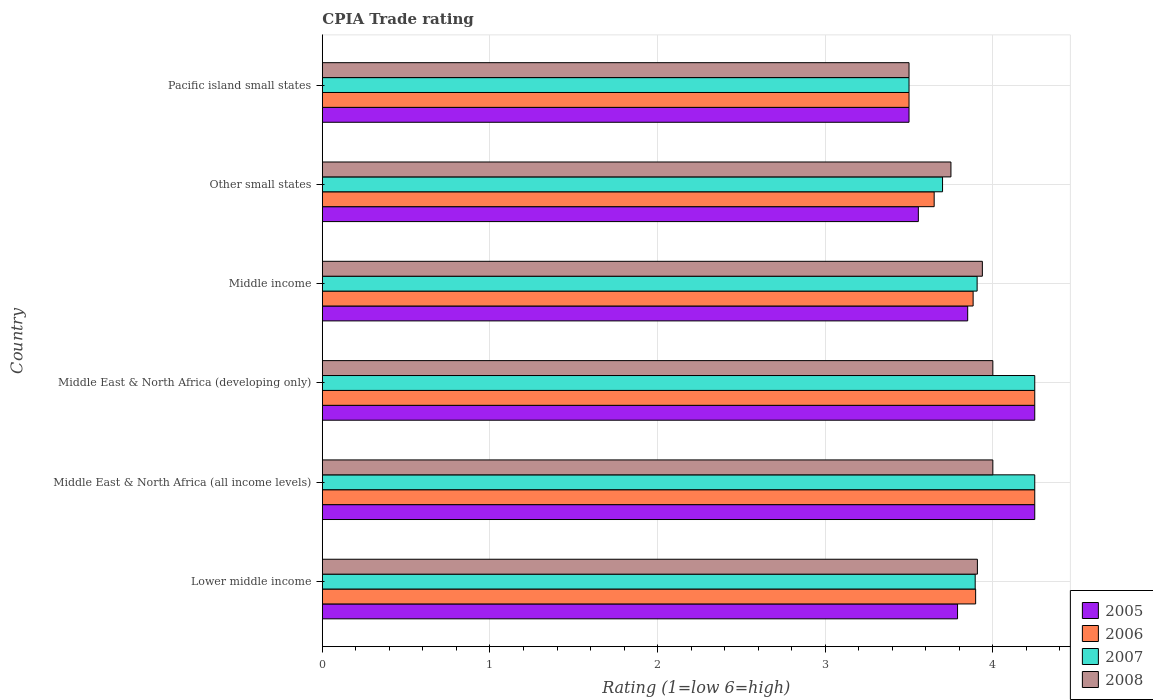Are the number of bars per tick equal to the number of legend labels?
Provide a short and direct response. Yes. How many bars are there on the 6th tick from the bottom?
Your answer should be compact. 4. What is the label of the 2nd group of bars from the top?
Offer a terse response. Other small states. In how many cases, is the number of bars for a given country not equal to the number of legend labels?
Keep it short and to the point. 0. What is the CPIA rating in 2008 in Other small states?
Provide a succinct answer. 3.75. Across all countries, what is the maximum CPIA rating in 2006?
Offer a very short reply. 4.25. Across all countries, what is the minimum CPIA rating in 2006?
Your answer should be very brief. 3.5. In which country was the CPIA rating in 2008 maximum?
Provide a short and direct response. Middle East & North Africa (all income levels). In which country was the CPIA rating in 2005 minimum?
Provide a succinct answer. Pacific island small states. What is the total CPIA rating in 2008 in the graph?
Ensure brevity in your answer.  23.1. What is the difference between the CPIA rating in 2008 in Middle East & North Africa (all income levels) and that in Middle East & North Africa (developing only)?
Your response must be concise. 0. What is the difference between the CPIA rating in 2005 in Middle East & North Africa (all income levels) and the CPIA rating in 2006 in Lower middle income?
Your response must be concise. 0.35. What is the average CPIA rating in 2007 per country?
Make the answer very short. 3.92. What is the ratio of the CPIA rating in 2006 in Middle East & North Africa (all income levels) to that in Pacific island small states?
Provide a succinct answer. 1.21. Is the difference between the CPIA rating in 2008 in Lower middle income and Pacific island small states greater than the difference between the CPIA rating in 2005 in Lower middle income and Pacific island small states?
Keep it short and to the point. Yes. What is the difference between the highest and the second highest CPIA rating in 2005?
Offer a terse response. 0. What does the 2nd bar from the bottom in Middle East & North Africa (all income levels) represents?
Give a very brief answer. 2006. Is it the case that in every country, the sum of the CPIA rating in 2007 and CPIA rating in 2005 is greater than the CPIA rating in 2006?
Ensure brevity in your answer.  Yes. How many bars are there?
Make the answer very short. 24. Are all the bars in the graph horizontal?
Your response must be concise. Yes. What is the difference between two consecutive major ticks on the X-axis?
Your answer should be compact. 1. Does the graph contain grids?
Your answer should be very brief. Yes. Where does the legend appear in the graph?
Make the answer very short. Bottom right. How are the legend labels stacked?
Ensure brevity in your answer.  Vertical. What is the title of the graph?
Your answer should be very brief. CPIA Trade rating. Does "1989" appear as one of the legend labels in the graph?
Your response must be concise. No. What is the label or title of the Y-axis?
Give a very brief answer. Country. What is the Rating (1=low 6=high) of 2005 in Lower middle income?
Provide a succinct answer. 3.79. What is the Rating (1=low 6=high) of 2006 in Lower middle income?
Keep it short and to the point. 3.9. What is the Rating (1=low 6=high) in 2007 in Lower middle income?
Provide a short and direct response. 3.89. What is the Rating (1=low 6=high) in 2008 in Lower middle income?
Your answer should be compact. 3.91. What is the Rating (1=low 6=high) in 2005 in Middle East & North Africa (all income levels)?
Keep it short and to the point. 4.25. What is the Rating (1=low 6=high) of 2006 in Middle East & North Africa (all income levels)?
Give a very brief answer. 4.25. What is the Rating (1=low 6=high) of 2007 in Middle East & North Africa (all income levels)?
Ensure brevity in your answer.  4.25. What is the Rating (1=low 6=high) of 2005 in Middle East & North Africa (developing only)?
Your answer should be compact. 4.25. What is the Rating (1=low 6=high) of 2006 in Middle East & North Africa (developing only)?
Give a very brief answer. 4.25. What is the Rating (1=low 6=high) in 2007 in Middle East & North Africa (developing only)?
Your answer should be compact. 4.25. What is the Rating (1=low 6=high) of 2005 in Middle income?
Your answer should be very brief. 3.85. What is the Rating (1=low 6=high) in 2006 in Middle income?
Make the answer very short. 3.88. What is the Rating (1=low 6=high) in 2007 in Middle income?
Keep it short and to the point. 3.91. What is the Rating (1=low 6=high) of 2008 in Middle income?
Your response must be concise. 3.94. What is the Rating (1=low 6=high) in 2005 in Other small states?
Keep it short and to the point. 3.56. What is the Rating (1=low 6=high) in 2006 in Other small states?
Offer a very short reply. 3.65. What is the Rating (1=low 6=high) of 2007 in Other small states?
Provide a succinct answer. 3.7. What is the Rating (1=low 6=high) of 2008 in Other small states?
Offer a terse response. 3.75. What is the Rating (1=low 6=high) in 2005 in Pacific island small states?
Offer a very short reply. 3.5. What is the Rating (1=low 6=high) of 2006 in Pacific island small states?
Offer a terse response. 3.5. What is the Rating (1=low 6=high) in 2007 in Pacific island small states?
Your answer should be compact. 3.5. What is the Rating (1=low 6=high) of 2008 in Pacific island small states?
Keep it short and to the point. 3.5. Across all countries, what is the maximum Rating (1=low 6=high) in 2005?
Your response must be concise. 4.25. Across all countries, what is the maximum Rating (1=low 6=high) in 2006?
Offer a very short reply. 4.25. Across all countries, what is the maximum Rating (1=low 6=high) in 2007?
Keep it short and to the point. 4.25. Across all countries, what is the maximum Rating (1=low 6=high) of 2008?
Provide a short and direct response. 4. Across all countries, what is the minimum Rating (1=low 6=high) in 2005?
Your response must be concise. 3.5. Across all countries, what is the minimum Rating (1=low 6=high) of 2008?
Provide a short and direct response. 3.5. What is the total Rating (1=low 6=high) of 2005 in the graph?
Provide a short and direct response. 23.2. What is the total Rating (1=low 6=high) in 2006 in the graph?
Give a very brief answer. 23.43. What is the total Rating (1=low 6=high) of 2007 in the graph?
Keep it short and to the point. 23.5. What is the total Rating (1=low 6=high) in 2008 in the graph?
Ensure brevity in your answer.  23.1. What is the difference between the Rating (1=low 6=high) of 2005 in Lower middle income and that in Middle East & North Africa (all income levels)?
Ensure brevity in your answer.  -0.46. What is the difference between the Rating (1=low 6=high) of 2006 in Lower middle income and that in Middle East & North Africa (all income levels)?
Offer a very short reply. -0.35. What is the difference between the Rating (1=low 6=high) in 2007 in Lower middle income and that in Middle East & North Africa (all income levels)?
Keep it short and to the point. -0.36. What is the difference between the Rating (1=low 6=high) of 2008 in Lower middle income and that in Middle East & North Africa (all income levels)?
Ensure brevity in your answer.  -0.09. What is the difference between the Rating (1=low 6=high) of 2005 in Lower middle income and that in Middle East & North Africa (developing only)?
Make the answer very short. -0.46. What is the difference between the Rating (1=low 6=high) in 2006 in Lower middle income and that in Middle East & North Africa (developing only)?
Give a very brief answer. -0.35. What is the difference between the Rating (1=low 6=high) of 2007 in Lower middle income and that in Middle East & North Africa (developing only)?
Your answer should be very brief. -0.36. What is the difference between the Rating (1=low 6=high) of 2008 in Lower middle income and that in Middle East & North Africa (developing only)?
Give a very brief answer. -0.09. What is the difference between the Rating (1=low 6=high) of 2005 in Lower middle income and that in Middle income?
Provide a succinct answer. -0.06. What is the difference between the Rating (1=low 6=high) in 2006 in Lower middle income and that in Middle income?
Your answer should be very brief. 0.02. What is the difference between the Rating (1=low 6=high) in 2007 in Lower middle income and that in Middle income?
Provide a short and direct response. -0.01. What is the difference between the Rating (1=low 6=high) of 2008 in Lower middle income and that in Middle income?
Offer a terse response. -0.03. What is the difference between the Rating (1=low 6=high) in 2005 in Lower middle income and that in Other small states?
Offer a very short reply. 0.23. What is the difference between the Rating (1=low 6=high) of 2006 in Lower middle income and that in Other small states?
Provide a short and direct response. 0.25. What is the difference between the Rating (1=low 6=high) of 2007 in Lower middle income and that in Other small states?
Provide a succinct answer. 0.19. What is the difference between the Rating (1=low 6=high) of 2008 in Lower middle income and that in Other small states?
Your answer should be compact. 0.16. What is the difference between the Rating (1=low 6=high) of 2005 in Lower middle income and that in Pacific island small states?
Provide a short and direct response. 0.29. What is the difference between the Rating (1=low 6=high) of 2006 in Lower middle income and that in Pacific island small states?
Your response must be concise. 0.4. What is the difference between the Rating (1=low 6=high) in 2007 in Lower middle income and that in Pacific island small states?
Ensure brevity in your answer.  0.39. What is the difference between the Rating (1=low 6=high) of 2008 in Lower middle income and that in Pacific island small states?
Offer a terse response. 0.41. What is the difference between the Rating (1=low 6=high) in 2005 in Middle East & North Africa (all income levels) and that in Middle East & North Africa (developing only)?
Offer a very short reply. 0. What is the difference between the Rating (1=low 6=high) of 2006 in Middle East & North Africa (all income levels) and that in Middle East & North Africa (developing only)?
Your response must be concise. 0. What is the difference between the Rating (1=low 6=high) of 2005 in Middle East & North Africa (all income levels) and that in Middle income?
Make the answer very short. 0.4. What is the difference between the Rating (1=low 6=high) of 2006 in Middle East & North Africa (all income levels) and that in Middle income?
Ensure brevity in your answer.  0.37. What is the difference between the Rating (1=low 6=high) in 2007 in Middle East & North Africa (all income levels) and that in Middle income?
Give a very brief answer. 0.34. What is the difference between the Rating (1=low 6=high) in 2008 in Middle East & North Africa (all income levels) and that in Middle income?
Ensure brevity in your answer.  0.06. What is the difference between the Rating (1=low 6=high) of 2005 in Middle East & North Africa (all income levels) and that in Other small states?
Ensure brevity in your answer.  0.69. What is the difference between the Rating (1=low 6=high) of 2007 in Middle East & North Africa (all income levels) and that in Other small states?
Ensure brevity in your answer.  0.55. What is the difference between the Rating (1=low 6=high) in 2008 in Middle East & North Africa (all income levels) and that in Other small states?
Ensure brevity in your answer.  0.25. What is the difference between the Rating (1=low 6=high) in 2008 in Middle East & North Africa (all income levels) and that in Pacific island small states?
Give a very brief answer. 0.5. What is the difference between the Rating (1=low 6=high) of 2006 in Middle East & North Africa (developing only) and that in Middle income?
Your response must be concise. 0.37. What is the difference between the Rating (1=low 6=high) in 2007 in Middle East & North Africa (developing only) and that in Middle income?
Make the answer very short. 0.34. What is the difference between the Rating (1=low 6=high) in 2008 in Middle East & North Africa (developing only) and that in Middle income?
Your answer should be very brief. 0.06. What is the difference between the Rating (1=low 6=high) in 2005 in Middle East & North Africa (developing only) and that in Other small states?
Your answer should be compact. 0.69. What is the difference between the Rating (1=low 6=high) in 2006 in Middle East & North Africa (developing only) and that in Other small states?
Provide a succinct answer. 0.6. What is the difference between the Rating (1=low 6=high) of 2007 in Middle East & North Africa (developing only) and that in Other small states?
Your answer should be very brief. 0.55. What is the difference between the Rating (1=low 6=high) of 2005 in Middle income and that in Other small states?
Offer a terse response. 0.29. What is the difference between the Rating (1=low 6=high) in 2006 in Middle income and that in Other small states?
Offer a terse response. 0.23. What is the difference between the Rating (1=low 6=high) in 2007 in Middle income and that in Other small states?
Offer a very short reply. 0.21. What is the difference between the Rating (1=low 6=high) of 2008 in Middle income and that in Other small states?
Offer a very short reply. 0.19. What is the difference between the Rating (1=low 6=high) in 2006 in Middle income and that in Pacific island small states?
Make the answer very short. 0.38. What is the difference between the Rating (1=low 6=high) of 2007 in Middle income and that in Pacific island small states?
Make the answer very short. 0.41. What is the difference between the Rating (1=low 6=high) of 2008 in Middle income and that in Pacific island small states?
Give a very brief answer. 0.44. What is the difference between the Rating (1=low 6=high) of 2005 in Other small states and that in Pacific island small states?
Offer a very short reply. 0.06. What is the difference between the Rating (1=low 6=high) in 2006 in Other small states and that in Pacific island small states?
Your answer should be compact. 0.15. What is the difference between the Rating (1=low 6=high) in 2007 in Other small states and that in Pacific island small states?
Your answer should be very brief. 0.2. What is the difference between the Rating (1=low 6=high) of 2005 in Lower middle income and the Rating (1=low 6=high) of 2006 in Middle East & North Africa (all income levels)?
Ensure brevity in your answer.  -0.46. What is the difference between the Rating (1=low 6=high) of 2005 in Lower middle income and the Rating (1=low 6=high) of 2007 in Middle East & North Africa (all income levels)?
Provide a short and direct response. -0.46. What is the difference between the Rating (1=low 6=high) of 2005 in Lower middle income and the Rating (1=low 6=high) of 2008 in Middle East & North Africa (all income levels)?
Ensure brevity in your answer.  -0.21. What is the difference between the Rating (1=low 6=high) in 2006 in Lower middle income and the Rating (1=low 6=high) in 2007 in Middle East & North Africa (all income levels)?
Offer a very short reply. -0.35. What is the difference between the Rating (1=low 6=high) in 2006 in Lower middle income and the Rating (1=low 6=high) in 2008 in Middle East & North Africa (all income levels)?
Provide a short and direct response. -0.1. What is the difference between the Rating (1=low 6=high) of 2007 in Lower middle income and the Rating (1=low 6=high) of 2008 in Middle East & North Africa (all income levels)?
Ensure brevity in your answer.  -0.11. What is the difference between the Rating (1=low 6=high) in 2005 in Lower middle income and the Rating (1=low 6=high) in 2006 in Middle East & North Africa (developing only)?
Give a very brief answer. -0.46. What is the difference between the Rating (1=low 6=high) of 2005 in Lower middle income and the Rating (1=low 6=high) of 2007 in Middle East & North Africa (developing only)?
Make the answer very short. -0.46. What is the difference between the Rating (1=low 6=high) in 2005 in Lower middle income and the Rating (1=low 6=high) in 2008 in Middle East & North Africa (developing only)?
Offer a terse response. -0.21. What is the difference between the Rating (1=low 6=high) in 2006 in Lower middle income and the Rating (1=low 6=high) in 2007 in Middle East & North Africa (developing only)?
Provide a succinct answer. -0.35. What is the difference between the Rating (1=low 6=high) of 2006 in Lower middle income and the Rating (1=low 6=high) of 2008 in Middle East & North Africa (developing only)?
Offer a terse response. -0.1. What is the difference between the Rating (1=low 6=high) in 2007 in Lower middle income and the Rating (1=low 6=high) in 2008 in Middle East & North Africa (developing only)?
Provide a short and direct response. -0.11. What is the difference between the Rating (1=low 6=high) in 2005 in Lower middle income and the Rating (1=low 6=high) in 2006 in Middle income?
Your response must be concise. -0.09. What is the difference between the Rating (1=low 6=high) in 2005 in Lower middle income and the Rating (1=low 6=high) in 2007 in Middle income?
Provide a short and direct response. -0.12. What is the difference between the Rating (1=low 6=high) of 2005 in Lower middle income and the Rating (1=low 6=high) of 2008 in Middle income?
Your answer should be compact. -0.15. What is the difference between the Rating (1=low 6=high) of 2006 in Lower middle income and the Rating (1=low 6=high) of 2007 in Middle income?
Your response must be concise. -0.01. What is the difference between the Rating (1=low 6=high) in 2006 in Lower middle income and the Rating (1=low 6=high) in 2008 in Middle income?
Provide a short and direct response. -0.04. What is the difference between the Rating (1=low 6=high) in 2007 in Lower middle income and the Rating (1=low 6=high) in 2008 in Middle income?
Provide a short and direct response. -0.04. What is the difference between the Rating (1=low 6=high) of 2005 in Lower middle income and the Rating (1=low 6=high) of 2006 in Other small states?
Keep it short and to the point. 0.14. What is the difference between the Rating (1=low 6=high) of 2005 in Lower middle income and the Rating (1=low 6=high) of 2007 in Other small states?
Provide a short and direct response. 0.09. What is the difference between the Rating (1=low 6=high) of 2005 in Lower middle income and the Rating (1=low 6=high) of 2008 in Other small states?
Keep it short and to the point. 0.04. What is the difference between the Rating (1=low 6=high) of 2006 in Lower middle income and the Rating (1=low 6=high) of 2007 in Other small states?
Offer a very short reply. 0.2. What is the difference between the Rating (1=low 6=high) in 2006 in Lower middle income and the Rating (1=low 6=high) in 2008 in Other small states?
Offer a very short reply. 0.15. What is the difference between the Rating (1=low 6=high) in 2007 in Lower middle income and the Rating (1=low 6=high) in 2008 in Other small states?
Give a very brief answer. 0.14. What is the difference between the Rating (1=low 6=high) of 2005 in Lower middle income and the Rating (1=low 6=high) of 2006 in Pacific island small states?
Your answer should be compact. 0.29. What is the difference between the Rating (1=low 6=high) of 2005 in Lower middle income and the Rating (1=low 6=high) of 2007 in Pacific island small states?
Your answer should be very brief. 0.29. What is the difference between the Rating (1=low 6=high) of 2005 in Lower middle income and the Rating (1=low 6=high) of 2008 in Pacific island small states?
Offer a terse response. 0.29. What is the difference between the Rating (1=low 6=high) in 2006 in Lower middle income and the Rating (1=low 6=high) in 2007 in Pacific island small states?
Make the answer very short. 0.4. What is the difference between the Rating (1=low 6=high) in 2006 in Lower middle income and the Rating (1=low 6=high) in 2008 in Pacific island small states?
Keep it short and to the point. 0.4. What is the difference between the Rating (1=low 6=high) in 2007 in Lower middle income and the Rating (1=low 6=high) in 2008 in Pacific island small states?
Your answer should be very brief. 0.39. What is the difference between the Rating (1=low 6=high) of 2005 in Middle East & North Africa (all income levels) and the Rating (1=low 6=high) of 2008 in Middle East & North Africa (developing only)?
Your answer should be very brief. 0.25. What is the difference between the Rating (1=low 6=high) in 2006 in Middle East & North Africa (all income levels) and the Rating (1=low 6=high) in 2007 in Middle East & North Africa (developing only)?
Your answer should be very brief. 0. What is the difference between the Rating (1=low 6=high) of 2005 in Middle East & North Africa (all income levels) and the Rating (1=low 6=high) of 2006 in Middle income?
Offer a terse response. 0.37. What is the difference between the Rating (1=low 6=high) of 2005 in Middle East & North Africa (all income levels) and the Rating (1=low 6=high) of 2007 in Middle income?
Make the answer very short. 0.34. What is the difference between the Rating (1=low 6=high) of 2005 in Middle East & North Africa (all income levels) and the Rating (1=low 6=high) of 2008 in Middle income?
Your answer should be very brief. 0.31. What is the difference between the Rating (1=low 6=high) of 2006 in Middle East & North Africa (all income levels) and the Rating (1=low 6=high) of 2007 in Middle income?
Give a very brief answer. 0.34. What is the difference between the Rating (1=low 6=high) of 2006 in Middle East & North Africa (all income levels) and the Rating (1=low 6=high) of 2008 in Middle income?
Provide a short and direct response. 0.31. What is the difference between the Rating (1=low 6=high) in 2007 in Middle East & North Africa (all income levels) and the Rating (1=low 6=high) in 2008 in Middle income?
Your answer should be very brief. 0.31. What is the difference between the Rating (1=low 6=high) in 2005 in Middle East & North Africa (all income levels) and the Rating (1=low 6=high) in 2007 in Other small states?
Keep it short and to the point. 0.55. What is the difference between the Rating (1=low 6=high) of 2006 in Middle East & North Africa (all income levels) and the Rating (1=low 6=high) of 2007 in Other small states?
Ensure brevity in your answer.  0.55. What is the difference between the Rating (1=low 6=high) of 2006 in Middle East & North Africa (all income levels) and the Rating (1=low 6=high) of 2008 in Other small states?
Offer a terse response. 0.5. What is the difference between the Rating (1=low 6=high) of 2007 in Middle East & North Africa (all income levels) and the Rating (1=low 6=high) of 2008 in Other small states?
Your answer should be compact. 0.5. What is the difference between the Rating (1=low 6=high) of 2005 in Middle East & North Africa (all income levels) and the Rating (1=low 6=high) of 2006 in Pacific island small states?
Your answer should be very brief. 0.75. What is the difference between the Rating (1=low 6=high) of 2005 in Middle East & North Africa (all income levels) and the Rating (1=low 6=high) of 2007 in Pacific island small states?
Keep it short and to the point. 0.75. What is the difference between the Rating (1=low 6=high) in 2005 in Middle East & North Africa (all income levels) and the Rating (1=low 6=high) in 2008 in Pacific island small states?
Your answer should be compact. 0.75. What is the difference between the Rating (1=low 6=high) in 2006 in Middle East & North Africa (all income levels) and the Rating (1=low 6=high) in 2008 in Pacific island small states?
Provide a succinct answer. 0.75. What is the difference between the Rating (1=low 6=high) in 2007 in Middle East & North Africa (all income levels) and the Rating (1=low 6=high) in 2008 in Pacific island small states?
Offer a terse response. 0.75. What is the difference between the Rating (1=low 6=high) of 2005 in Middle East & North Africa (developing only) and the Rating (1=low 6=high) of 2006 in Middle income?
Provide a short and direct response. 0.37. What is the difference between the Rating (1=low 6=high) of 2005 in Middle East & North Africa (developing only) and the Rating (1=low 6=high) of 2007 in Middle income?
Provide a succinct answer. 0.34. What is the difference between the Rating (1=low 6=high) in 2005 in Middle East & North Africa (developing only) and the Rating (1=low 6=high) in 2008 in Middle income?
Your answer should be very brief. 0.31. What is the difference between the Rating (1=low 6=high) of 2006 in Middle East & North Africa (developing only) and the Rating (1=low 6=high) of 2007 in Middle income?
Your response must be concise. 0.34. What is the difference between the Rating (1=low 6=high) of 2006 in Middle East & North Africa (developing only) and the Rating (1=low 6=high) of 2008 in Middle income?
Ensure brevity in your answer.  0.31. What is the difference between the Rating (1=low 6=high) of 2007 in Middle East & North Africa (developing only) and the Rating (1=low 6=high) of 2008 in Middle income?
Provide a succinct answer. 0.31. What is the difference between the Rating (1=low 6=high) of 2005 in Middle East & North Africa (developing only) and the Rating (1=low 6=high) of 2007 in Other small states?
Your response must be concise. 0.55. What is the difference between the Rating (1=low 6=high) of 2006 in Middle East & North Africa (developing only) and the Rating (1=low 6=high) of 2007 in Other small states?
Make the answer very short. 0.55. What is the difference between the Rating (1=low 6=high) of 2006 in Middle East & North Africa (developing only) and the Rating (1=low 6=high) of 2008 in Other small states?
Your answer should be compact. 0.5. What is the difference between the Rating (1=low 6=high) of 2005 in Middle East & North Africa (developing only) and the Rating (1=low 6=high) of 2006 in Pacific island small states?
Make the answer very short. 0.75. What is the difference between the Rating (1=low 6=high) of 2005 in Middle East & North Africa (developing only) and the Rating (1=low 6=high) of 2007 in Pacific island small states?
Ensure brevity in your answer.  0.75. What is the difference between the Rating (1=low 6=high) in 2005 in Middle East & North Africa (developing only) and the Rating (1=low 6=high) in 2008 in Pacific island small states?
Your response must be concise. 0.75. What is the difference between the Rating (1=low 6=high) in 2006 in Middle East & North Africa (developing only) and the Rating (1=low 6=high) in 2008 in Pacific island small states?
Offer a very short reply. 0.75. What is the difference between the Rating (1=low 6=high) of 2006 in Middle income and the Rating (1=low 6=high) of 2007 in Other small states?
Keep it short and to the point. 0.18. What is the difference between the Rating (1=low 6=high) in 2006 in Middle income and the Rating (1=low 6=high) in 2008 in Other small states?
Offer a very short reply. 0.13. What is the difference between the Rating (1=low 6=high) of 2007 in Middle income and the Rating (1=low 6=high) of 2008 in Other small states?
Provide a succinct answer. 0.16. What is the difference between the Rating (1=low 6=high) of 2005 in Middle income and the Rating (1=low 6=high) of 2006 in Pacific island small states?
Offer a very short reply. 0.35. What is the difference between the Rating (1=low 6=high) in 2005 in Middle income and the Rating (1=low 6=high) in 2007 in Pacific island small states?
Provide a short and direct response. 0.35. What is the difference between the Rating (1=low 6=high) of 2006 in Middle income and the Rating (1=low 6=high) of 2007 in Pacific island small states?
Offer a terse response. 0.38. What is the difference between the Rating (1=low 6=high) in 2006 in Middle income and the Rating (1=low 6=high) in 2008 in Pacific island small states?
Your answer should be compact. 0.38. What is the difference between the Rating (1=low 6=high) of 2007 in Middle income and the Rating (1=low 6=high) of 2008 in Pacific island small states?
Offer a very short reply. 0.41. What is the difference between the Rating (1=low 6=high) of 2005 in Other small states and the Rating (1=low 6=high) of 2006 in Pacific island small states?
Provide a succinct answer. 0.06. What is the difference between the Rating (1=low 6=high) in 2005 in Other small states and the Rating (1=low 6=high) in 2007 in Pacific island small states?
Ensure brevity in your answer.  0.06. What is the difference between the Rating (1=low 6=high) of 2005 in Other small states and the Rating (1=low 6=high) of 2008 in Pacific island small states?
Offer a terse response. 0.06. What is the difference between the Rating (1=low 6=high) in 2007 in Other small states and the Rating (1=low 6=high) in 2008 in Pacific island small states?
Make the answer very short. 0.2. What is the average Rating (1=low 6=high) of 2005 per country?
Offer a very short reply. 3.87. What is the average Rating (1=low 6=high) of 2006 per country?
Make the answer very short. 3.9. What is the average Rating (1=low 6=high) of 2007 per country?
Your response must be concise. 3.92. What is the average Rating (1=low 6=high) of 2008 per country?
Your answer should be very brief. 3.85. What is the difference between the Rating (1=low 6=high) of 2005 and Rating (1=low 6=high) of 2006 in Lower middle income?
Provide a succinct answer. -0.11. What is the difference between the Rating (1=low 6=high) of 2005 and Rating (1=low 6=high) of 2007 in Lower middle income?
Keep it short and to the point. -0.11. What is the difference between the Rating (1=low 6=high) of 2005 and Rating (1=low 6=high) of 2008 in Lower middle income?
Provide a succinct answer. -0.12. What is the difference between the Rating (1=low 6=high) of 2006 and Rating (1=low 6=high) of 2007 in Lower middle income?
Give a very brief answer. 0. What is the difference between the Rating (1=low 6=high) of 2006 and Rating (1=low 6=high) of 2008 in Lower middle income?
Offer a very short reply. -0.01. What is the difference between the Rating (1=low 6=high) in 2007 and Rating (1=low 6=high) in 2008 in Lower middle income?
Your response must be concise. -0.01. What is the difference between the Rating (1=low 6=high) of 2005 and Rating (1=low 6=high) of 2008 in Middle East & North Africa (all income levels)?
Offer a terse response. 0.25. What is the difference between the Rating (1=low 6=high) of 2006 and Rating (1=low 6=high) of 2007 in Middle East & North Africa (all income levels)?
Provide a short and direct response. 0. What is the difference between the Rating (1=low 6=high) in 2007 and Rating (1=low 6=high) in 2008 in Middle East & North Africa (all income levels)?
Make the answer very short. 0.25. What is the difference between the Rating (1=low 6=high) of 2005 and Rating (1=low 6=high) of 2007 in Middle East & North Africa (developing only)?
Keep it short and to the point. 0. What is the difference between the Rating (1=low 6=high) in 2005 and Rating (1=low 6=high) in 2008 in Middle East & North Africa (developing only)?
Your response must be concise. 0.25. What is the difference between the Rating (1=low 6=high) in 2006 and Rating (1=low 6=high) in 2007 in Middle East & North Africa (developing only)?
Keep it short and to the point. 0. What is the difference between the Rating (1=low 6=high) in 2007 and Rating (1=low 6=high) in 2008 in Middle East & North Africa (developing only)?
Provide a short and direct response. 0.25. What is the difference between the Rating (1=low 6=high) of 2005 and Rating (1=low 6=high) of 2006 in Middle income?
Your response must be concise. -0.03. What is the difference between the Rating (1=low 6=high) of 2005 and Rating (1=low 6=high) of 2007 in Middle income?
Ensure brevity in your answer.  -0.06. What is the difference between the Rating (1=low 6=high) in 2005 and Rating (1=low 6=high) in 2008 in Middle income?
Keep it short and to the point. -0.09. What is the difference between the Rating (1=low 6=high) in 2006 and Rating (1=low 6=high) in 2007 in Middle income?
Keep it short and to the point. -0.02. What is the difference between the Rating (1=low 6=high) in 2006 and Rating (1=low 6=high) in 2008 in Middle income?
Keep it short and to the point. -0.06. What is the difference between the Rating (1=low 6=high) of 2007 and Rating (1=low 6=high) of 2008 in Middle income?
Ensure brevity in your answer.  -0.03. What is the difference between the Rating (1=low 6=high) in 2005 and Rating (1=low 6=high) in 2006 in Other small states?
Your answer should be very brief. -0.09. What is the difference between the Rating (1=low 6=high) of 2005 and Rating (1=low 6=high) of 2007 in Other small states?
Offer a terse response. -0.14. What is the difference between the Rating (1=low 6=high) of 2005 and Rating (1=low 6=high) of 2008 in Other small states?
Your response must be concise. -0.19. What is the difference between the Rating (1=low 6=high) of 2006 and Rating (1=low 6=high) of 2007 in Other small states?
Provide a short and direct response. -0.05. What is the difference between the Rating (1=low 6=high) in 2006 and Rating (1=low 6=high) in 2008 in Other small states?
Your answer should be compact. -0.1. What is the difference between the Rating (1=low 6=high) in 2005 and Rating (1=low 6=high) in 2008 in Pacific island small states?
Your answer should be very brief. 0. What is the difference between the Rating (1=low 6=high) in 2006 and Rating (1=low 6=high) in 2007 in Pacific island small states?
Your answer should be very brief. 0. What is the difference between the Rating (1=low 6=high) in 2007 and Rating (1=low 6=high) in 2008 in Pacific island small states?
Your answer should be compact. 0. What is the ratio of the Rating (1=low 6=high) in 2005 in Lower middle income to that in Middle East & North Africa (all income levels)?
Your answer should be very brief. 0.89. What is the ratio of the Rating (1=low 6=high) in 2006 in Lower middle income to that in Middle East & North Africa (all income levels)?
Offer a terse response. 0.92. What is the ratio of the Rating (1=low 6=high) of 2007 in Lower middle income to that in Middle East & North Africa (all income levels)?
Provide a succinct answer. 0.92. What is the ratio of the Rating (1=low 6=high) of 2005 in Lower middle income to that in Middle East & North Africa (developing only)?
Provide a succinct answer. 0.89. What is the ratio of the Rating (1=low 6=high) in 2006 in Lower middle income to that in Middle East & North Africa (developing only)?
Ensure brevity in your answer.  0.92. What is the ratio of the Rating (1=low 6=high) in 2007 in Lower middle income to that in Middle East & North Africa (developing only)?
Your response must be concise. 0.92. What is the ratio of the Rating (1=low 6=high) in 2008 in Lower middle income to that in Middle East & North Africa (developing only)?
Provide a short and direct response. 0.98. What is the ratio of the Rating (1=low 6=high) of 2005 in Lower middle income to that in Middle income?
Offer a very short reply. 0.98. What is the ratio of the Rating (1=low 6=high) of 2006 in Lower middle income to that in Middle income?
Provide a short and direct response. 1. What is the ratio of the Rating (1=low 6=high) of 2007 in Lower middle income to that in Middle income?
Make the answer very short. 1. What is the ratio of the Rating (1=low 6=high) of 2005 in Lower middle income to that in Other small states?
Your answer should be compact. 1.07. What is the ratio of the Rating (1=low 6=high) in 2006 in Lower middle income to that in Other small states?
Your response must be concise. 1.07. What is the ratio of the Rating (1=low 6=high) of 2007 in Lower middle income to that in Other small states?
Your answer should be very brief. 1.05. What is the ratio of the Rating (1=low 6=high) in 2008 in Lower middle income to that in Other small states?
Keep it short and to the point. 1.04. What is the ratio of the Rating (1=low 6=high) of 2005 in Lower middle income to that in Pacific island small states?
Offer a very short reply. 1.08. What is the ratio of the Rating (1=low 6=high) in 2006 in Lower middle income to that in Pacific island small states?
Your answer should be compact. 1.11. What is the ratio of the Rating (1=low 6=high) in 2007 in Lower middle income to that in Pacific island small states?
Your answer should be very brief. 1.11. What is the ratio of the Rating (1=low 6=high) of 2008 in Lower middle income to that in Pacific island small states?
Offer a terse response. 1.12. What is the ratio of the Rating (1=low 6=high) of 2005 in Middle East & North Africa (all income levels) to that in Middle East & North Africa (developing only)?
Make the answer very short. 1. What is the ratio of the Rating (1=low 6=high) in 2006 in Middle East & North Africa (all income levels) to that in Middle East & North Africa (developing only)?
Make the answer very short. 1. What is the ratio of the Rating (1=low 6=high) of 2007 in Middle East & North Africa (all income levels) to that in Middle East & North Africa (developing only)?
Provide a succinct answer. 1. What is the ratio of the Rating (1=low 6=high) of 2008 in Middle East & North Africa (all income levels) to that in Middle East & North Africa (developing only)?
Give a very brief answer. 1. What is the ratio of the Rating (1=low 6=high) of 2005 in Middle East & North Africa (all income levels) to that in Middle income?
Ensure brevity in your answer.  1.1. What is the ratio of the Rating (1=low 6=high) of 2006 in Middle East & North Africa (all income levels) to that in Middle income?
Give a very brief answer. 1.09. What is the ratio of the Rating (1=low 6=high) in 2007 in Middle East & North Africa (all income levels) to that in Middle income?
Provide a succinct answer. 1.09. What is the ratio of the Rating (1=low 6=high) of 2008 in Middle East & North Africa (all income levels) to that in Middle income?
Offer a terse response. 1.02. What is the ratio of the Rating (1=low 6=high) of 2005 in Middle East & North Africa (all income levels) to that in Other small states?
Provide a succinct answer. 1.2. What is the ratio of the Rating (1=low 6=high) in 2006 in Middle East & North Africa (all income levels) to that in Other small states?
Your answer should be compact. 1.16. What is the ratio of the Rating (1=low 6=high) in 2007 in Middle East & North Africa (all income levels) to that in Other small states?
Your answer should be compact. 1.15. What is the ratio of the Rating (1=low 6=high) in 2008 in Middle East & North Africa (all income levels) to that in Other small states?
Provide a succinct answer. 1.07. What is the ratio of the Rating (1=low 6=high) in 2005 in Middle East & North Africa (all income levels) to that in Pacific island small states?
Your response must be concise. 1.21. What is the ratio of the Rating (1=low 6=high) of 2006 in Middle East & North Africa (all income levels) to that in Pacific island small states?
Keep it short and to the point. 1.21. What is the ratio of the Rating (1=low 6=high) of 2007 in Middle East & North Africa (all income levels) to that in Pacific island small states?
Keep it short and to the point. 1.21. What is the ratio of the Rating (1=low 6=high) in 2005 in Middle East & North Africa (developing only) to that in Middle income?
Offer a very short reply. 1.1. What is the ratio of the Rating (1=low 6=high) of 2006 in Middle East & North Africa (developing only) to that in Middle income?
Offer a very short reply. 1.09. What is the ratio of the Rating (1=low 6=high) in 2007 in Middle East & North Africa (developing only) to that in Middle income?
Offer a very short reply. 1.09. What is the ratio of the Rating (1=low 6=high) in 2008 in Middle East & North Africa (developing only) to that in Middle income?
Make the answer very short. 1.02. What is the ratio of the Rating (1=low 6=high) of 2005 in Middle East & North Africa (developing only) to that in Other small states?
Your answer should be very brief. 1.2. What is the ratio of the Rating (1=low 6=high) in 2006 in Middle East & North Africa (developing only) to that in Other small states?
Provide a short and direct response. 1.16. What is the ratio of the Rating (1=low 6=high) in 2007 in Middle East & North Africa (developing only) to that in Other small states?
Provide a succinct answer. 1.15. What is the ratio of the Rating (1=low 6=high) of 2008 in Middle East & North Africa (developing only) to that in Other small states?
Give a very brief answer. 1.07. What is the ratio of the Rating (1=low 6=high) in 2005 in Middle East & North Africa (developing only) to that in Pacific island small states?
Your answer should be compact. 1.21. What is the ratio of the Rating (1=low 6=high) of 2006 in Middle East & North Africa (developing only) to that in Pacific island small states?
Your response must be concise. 1.21. What is the ratio of the Rating (1=low 6=high) of 2007 in Middle East & North Africa (developing only) to that in Pacific island small states?
Offer a terse response. 1.21. What is the ratio of the Rating (1=low 6=high) of 2008 in Middle East & North Africa (developing only) to that in Pacific island small states?
Provide a short and direct response. 1.14. What is the ratio of the Rating (1=low 6=high) in 2005 in Middle income to that in Other small states?
Your response must be concise. 1.08. What is the ratio of the Rating (1=low 6=high) in 2006 in Middle income to that in Other small states?
Make the answer very short. 1.06. What is the ratio of the Rating (1=low 6=high) in 2007 in Middle income to that in Other small states?
Your answer should be very brief. 1.06. What is the ratio of the Rating (1=low 6=high) of 2008 in Middle income to that in Other small states?
Give a very brief answer. 1.05. What is the ratio of the Rating (1=low 6=high) in 2005 in Middle income to that in Pacific island small states?
Provide a short and direct response. 1.1. What is the ratio of the Rating (1=low 6=high) in 2006 in Middle income to that in Pacific island small states?
Provide a succinct answer. 1.11. What is the ratio of the Rating (1=low 6=high) in 2007 in Middle income to that in Pacific island small states?
Your response must be concise. 1.12. What is the ratio of the Rating (1=low 6=high) of 2008 in Middle income to that in Pacific island small states?
Give a very brief answer. 1.12. What is the ratio of the Rating (1=low 6=high) of 2005 in Other small states to that in Pacific island small states?
Give a very brief answer. 1.02. What is the ratio of the Rating (1=low 6=high) in 2006 in Other small states to that in Pacific island small states?
Make the answer very short. 1.04. What is the ratio of the Rating (1=low 6=high) in 2007 in Other small states to that in Pacific island small states?
Offer a very short reply. 1.06. What is the ratio of the Rating (1=low 6=high) in 2008 in Other small states to that in Pacific island small states?
Offer a terse response. 1.07. What is the difference between the highest and the lowest Rating (1=low 6=high) in 2006?
Your answer should be compact. 0.75. 